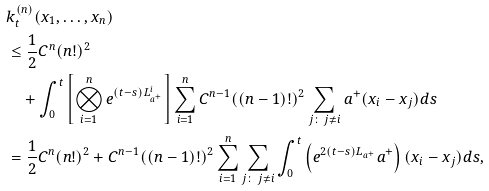Convert formula to latex. <formula><loc_0><loc_0><loc_500><loc_500>& k _ { t } ^ { ( n ) } ( x _ { 1 } , \dots , x _ { n } ) \\ & \leq \frac { 1 } { 2 } C ^ { n } ( n ! ) ^ { 2 } \\ & \quad + \int _ { 0 } ^ { t } \left [ \bigotimes _ { i = 1 } ^ { n } e ^ { ( t - s ) L _ { a ^ { + } } ^ { i } } \right ] \sum _ { i = 1 } ^ { n } C ^ { n - 1 } ( ( n - 1 ) ! ) ^ { 2 } \sum _ { j \colon \, j \neq i } a ^ { + } ( x _ { i } - x _ { j } ) d s \\ & = \frac { 1 } { 2 } C ^ { n } ( n ! ) ^ { 2 } + C ^ { n - 1 } ( ( n - 1 ) ! ) ^ { 2 } \sum _ { i = 1 } ^ { n } \sum _ { j \colon \, j \neq i } \int _ { 0 } ^ { t } \left ( e ^ { 2 ( t - s ) L _ { a ^ { + } } } a ^ { + } \right ) ( x _ { i } - x _ { j } ) d s ,</formula> 